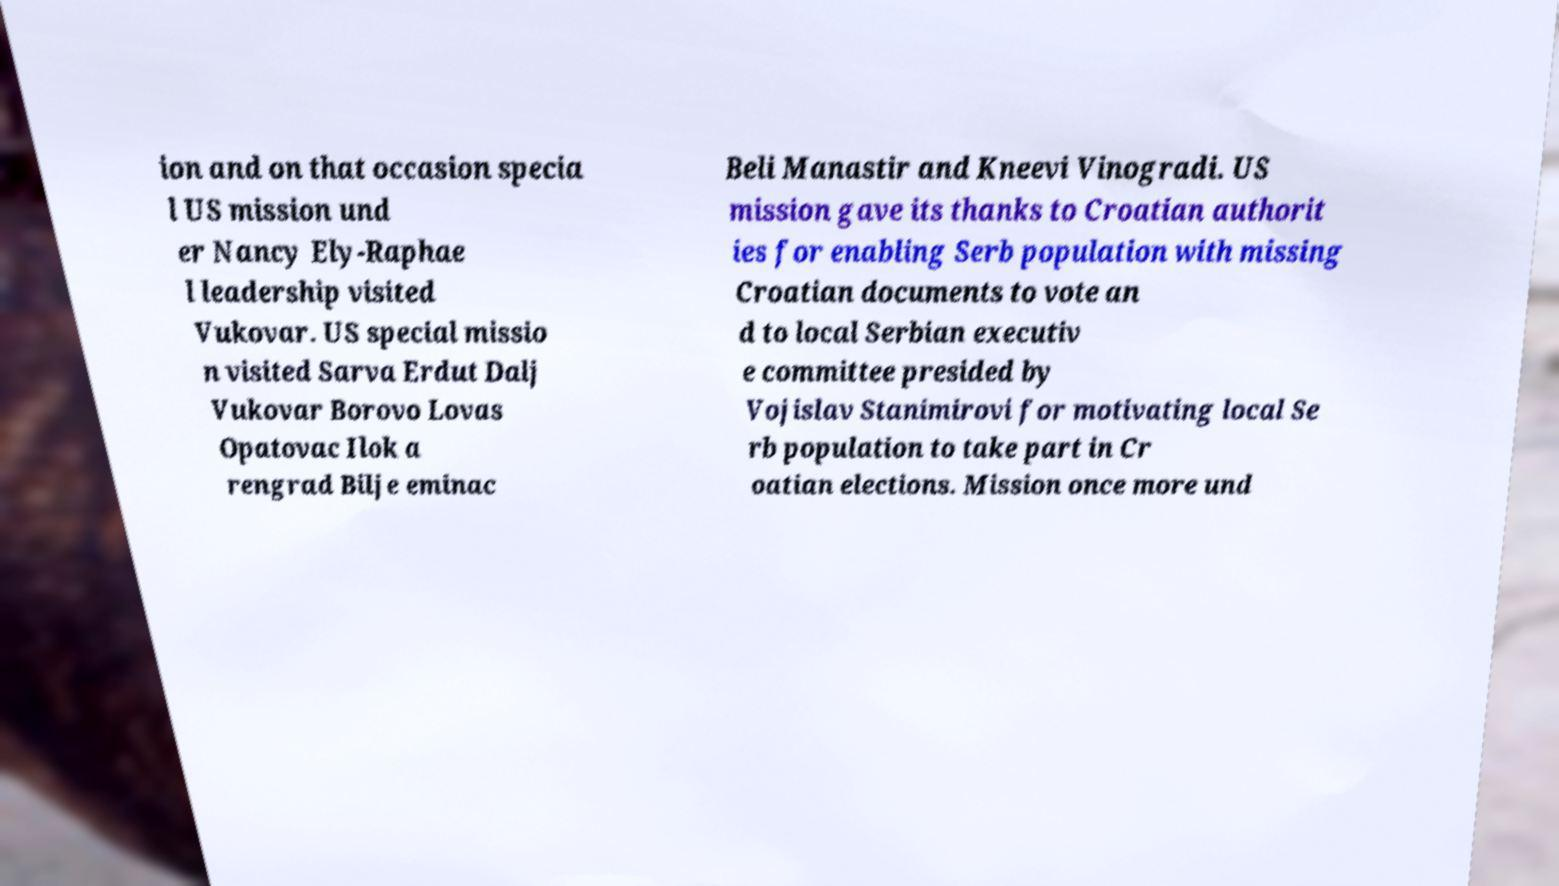Could you extract and type out the text from this image? ion and on that occasion specia l US mission und er Nancy Ely-Raphae l leadership visited Vukovar. US special missio n visited Sarva Erdut Dalj Vukovar Borovo Lovas Opatovac Ilok a rengrad Bilje eminac Beli Manastir and Kneevi Vinogradi. US mission gave its thanks to Croatian authorit ies for enabling Serb population with missing Croatian documents to vote an d to local Serbian executiv e committee presided by Vojislav Stanimirovi for motivating local Se rb population to take part in Cr oatian elections. Mission once more und 